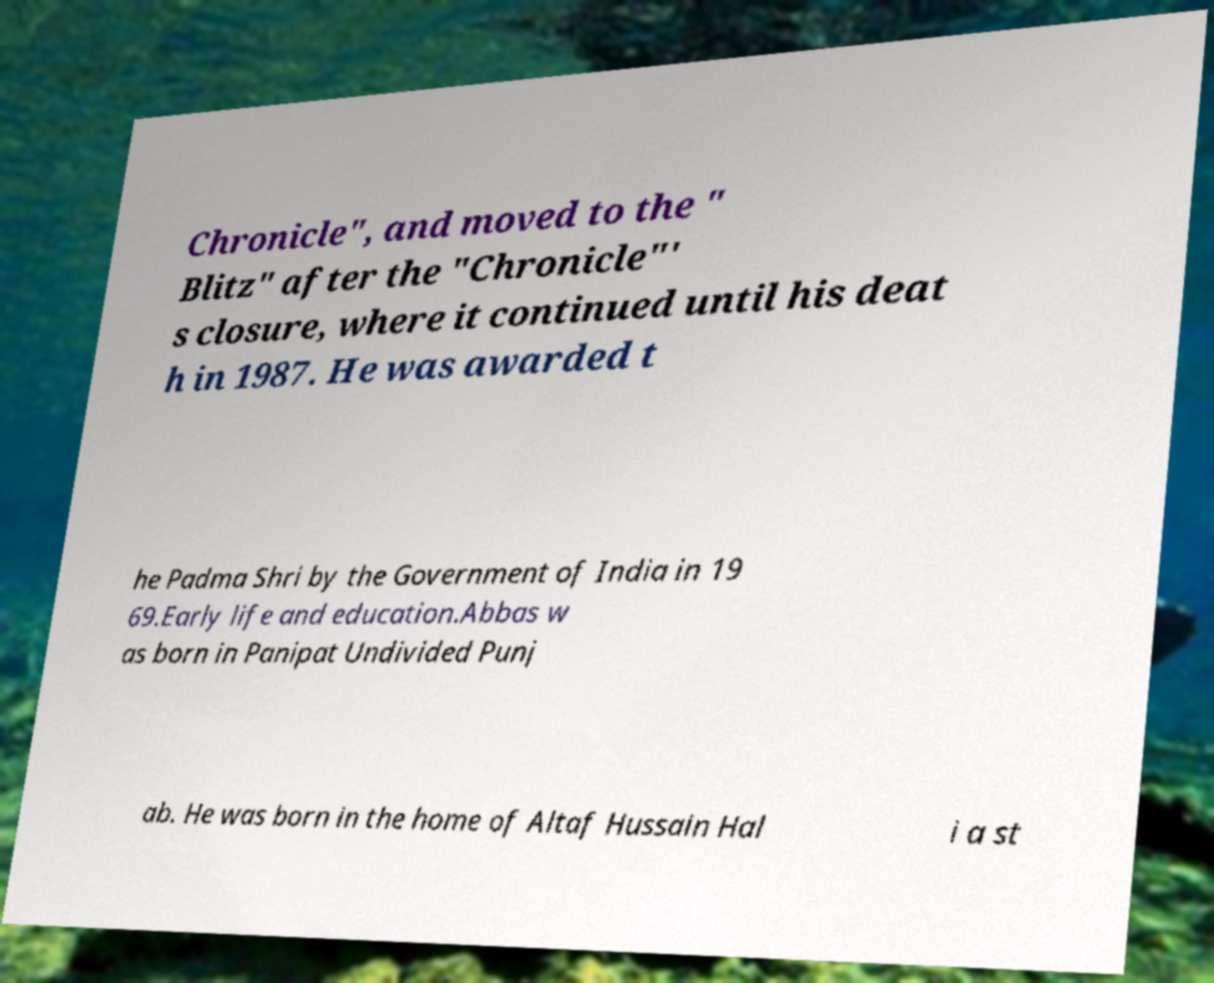Please identify and transcribe the text found in this image. Chronicle", and moved to the " Blitz" after the "Chronicle"' s closure, where it continued until his deat h in 1987. He was awarded t he Padma Shri by the Government of India in 19 69.Early life and education.Abbas w as born in Panipat Undivided Punj ab. He was born in the home of Altaf Hussain Hal i a st 